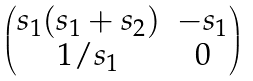Convert formula to latex. <formula><loc_0><loc_0><loc_500><loc_500>\begin{pmatrix} s _ { 1 } ( s _ { 1 } + s _ { 2 } ) & - s _ { 1 } \\ 1 / s _ { 1 } & 0 \end{pmatrix}</formula> 